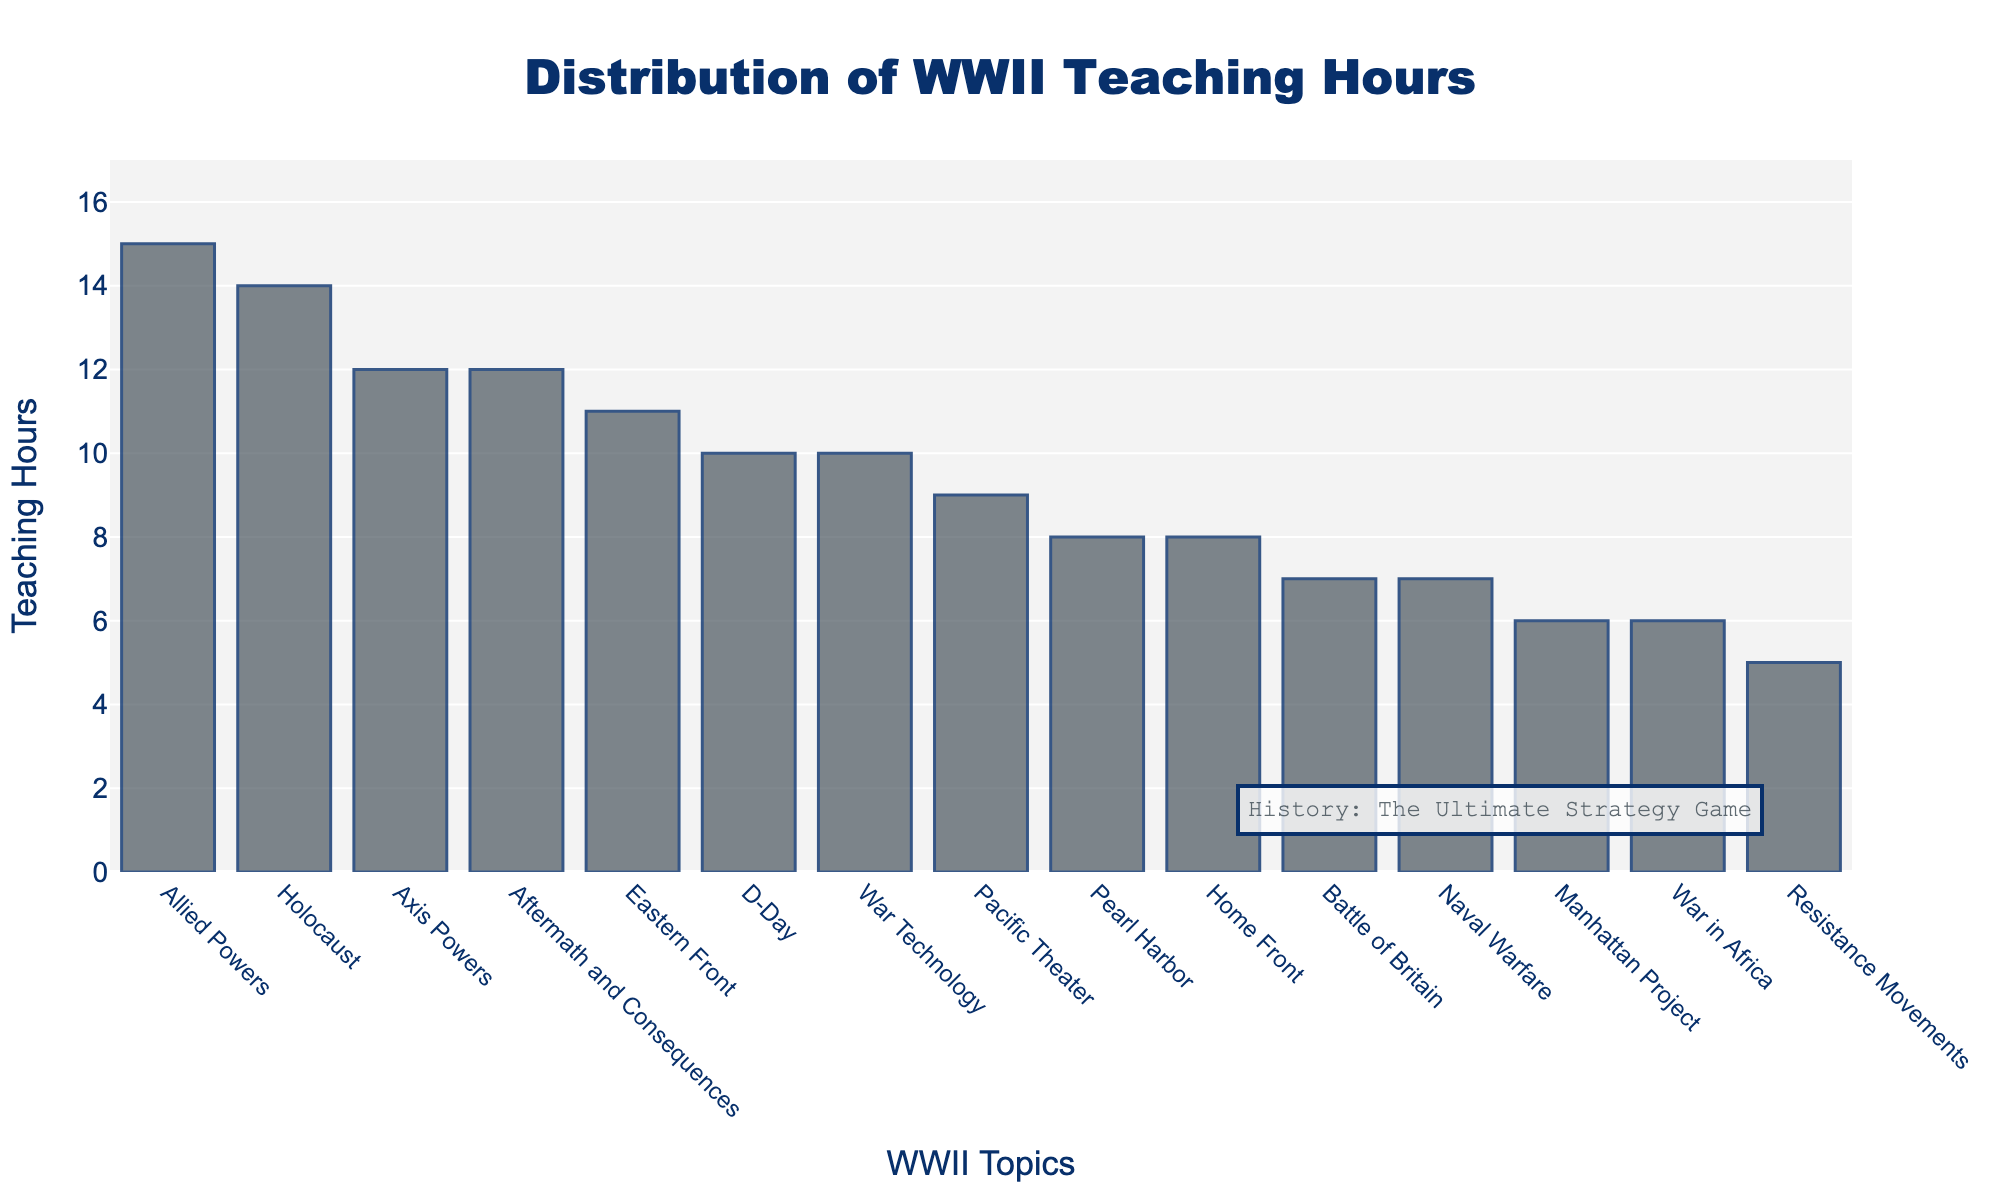How many topics are included in the histogram? Count the number of bars displayed, each bar represents a topic. There are 15 bars, so there are 15 topics included.
Answer: 15 Which topic has the highest number of teaching hours? Identify the tallest bar in the histogram, which represents the topic with the most teaching hours. "Allied Powers" is the tallest bar with 15 hours.
Answer: Allied Powers What is the range of teaching hours covered in the histogram? Find the difference between the longest (15 hours for "Allied Powers") and the shortest bar (5 hours for "Resistance Movements"). So, the range is 15 - 5 = 10.
Answer: 10 hours What is the average number of teaching hours per topic? Sum all the hours from each topic (15 + 12 + 8 + 10 + 14 + 9 + 11 + 7 + 6 + 8 + 10 + 5 + 7 + 6 + 12 = 140), then divide by the number of topics (15). 140 / 15 ≈ 9.33.
Answer: 9.33 hours How many topics have more than 10 teaching hours? Count the bars that have a value greater than 10. These are: "Allied Powers" (15), "Axis Powers" (12), and "Holocaust" (14), "Aftermath and Consequences" (12), and "Eastern Front" (11). There are 5 topics.
Answer: 5 Which topic has exactly 6 teaching hours? Identify the bar that corresponds to 6 hours. The topics with 6 hours are "Manhattan Project" and "War in Africa."
Answer: Manhattan Project, War in Africa Which topic has the least number of teaching hours, and how many hours is it? Identify the shortest bar in the histogram, which represents the topic with the fewest teaching hours. "Resistance Movements" is the shortest with 5 hours.
Answer: Resistance Movements, 5 What are the total teaching hours spent on "Home Front" and "War Technology" combined? Add the number of teaching hours for "Home Front" (8) and "War Technology" (10). 8 + 10 = 18.
Answer: 18 hours Which topic covers more teaching hours: "D-Day" or "Pacific Theater"? Compare the heights of the bars representing "D-Day" (10 hours) and "Pacific Theater" (9 hours). "D-Day" covers more hours than "Pacific Theater."
Answer: D-Day By how many hours do the teaching hours on "Holocaust" exceed those on "Pearl Harbor"? Subtract the hours of "Pearl Harbor" (8) from "Holocaust" (14). 14 - 8 = 6.
Answer: 6 hours 